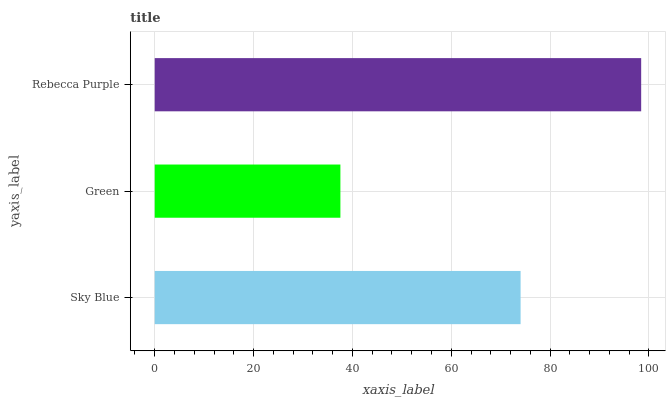Is Green the minimum?
Answer yes or no. Yes. Is Rebecca Purple the maximum?
Answer yes or no. Yes. Is Rebecca Purple the minimum?
Answer yes or no. No. Is Green the maximum?
Answer yes or no. No. Is Rebecca Purple greater than Green?
Answer yes or no. Yes. Is Green less than Rebecca Purple?
Answer yes or no. Yes. Is Green greater than Rebecca Purple?
Answer yes or no. No. Is Rebecca Purple less than Green?
Answer yes or no. No. Is Sky Blue the high median?
Answer yes or no. Yes. Is Sky Blue the low median?
Answer yes or no. Yes. Is Green the high median?
Answer yes or no. No. Is Rebecca Purple the low median?
Answer yes or no. No. 